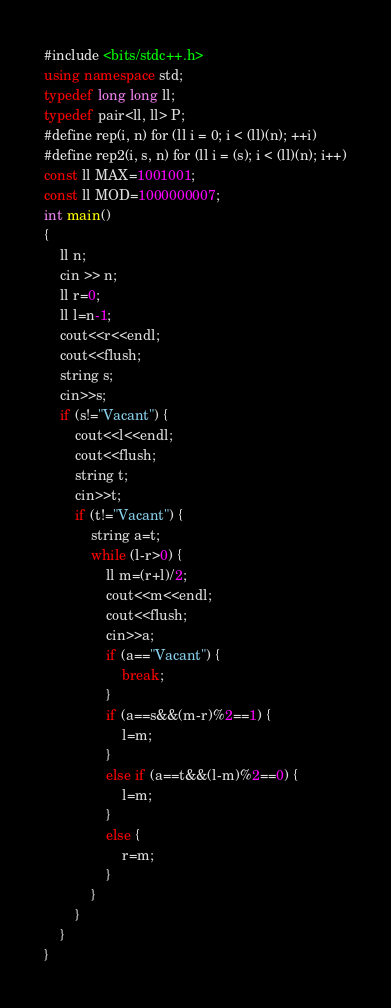<code> <loc_0><loc_0><loc_500><loc_500><_C++_>#include <bits/stdc++.h>
using namespace std;
typedef long long ll;
typedef pair<ll, ll> P;
#define rep(i, n) for (ll i = 0; i < (ll)(n); ++i)
#define rep2(i, s, n) for (ll i = (s); i < (ll)(n); i++)
const ll MAX=1001001;
const ll MOD=1000000007;
int main()
{
    ll n;
    cin >> n;
    ll r=0;
    ll l=n-1;
    cout<<r<<endl;
    cout<<flush;
    string s;
    cin>>s;
    if (s!="Vacant") {
        cout<<l<<endl;
        cout<<flush;
        string t;
        cin>>t;
        if (t!="Vacant") {
            string a=t;
            while (l-r>0) {
                ll m=(r+l)/2;
                cout<<m<<endl;
                cout<<flush;
                cin>>a;
                if (a=="Vacant") {
                    break;
                }
                if (a==s&&(m-r)%2==1) {
                    l=m;
                }
                else if (a==t&&(l-m)%2==0) {
                    l=m;
                }
                else {
                    r=m;
                }
            }
        }
    }
}
</code> 